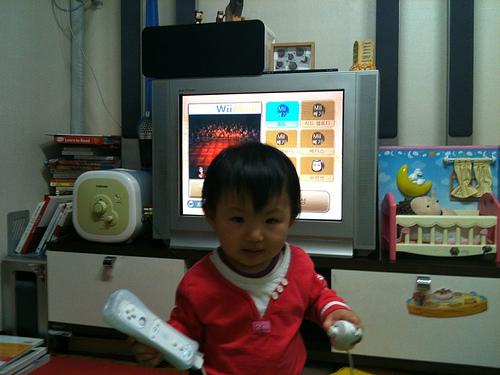What is the little child doing?
Concise answer only. Playing wii. Is this a professional office?
Answer briefly. No. What type of system does this controller go to?
Keep it brief. Wii. What is the name of one of the books?
Concise answer only. Learn to read. Is this at a school?
Short answer required. No. 